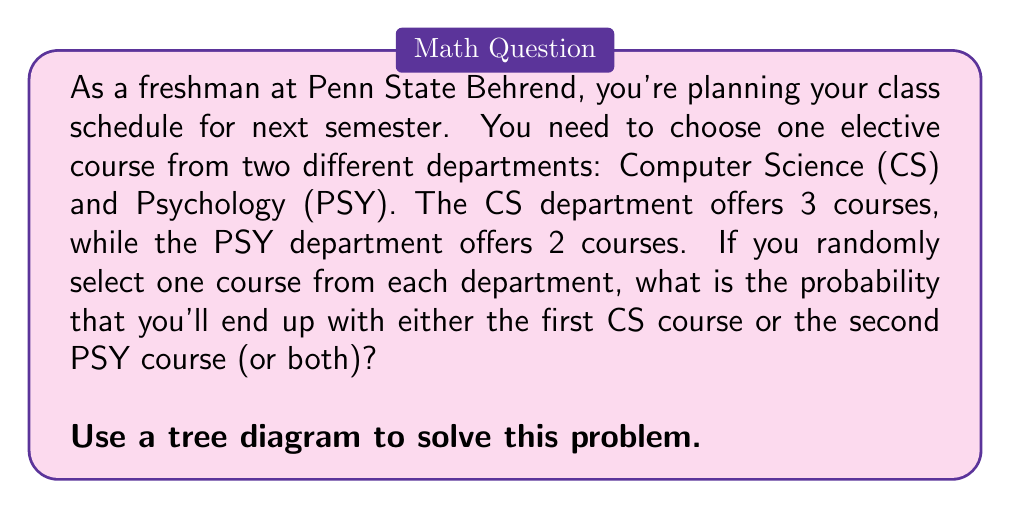Show me your answer to this math problem. Let's approach this step-by-step using a tree diagram:

1) First, let's create our tree diagram:

[asy]
unitsize(1cm);

// Main branches
draw((0,0)--(2,1));
draw((0,0)--(2,0));
draw((0,0)--(2,-1));

// Sub-branches
draw((2,1)--(4,1.5));
draw((2,1)--(4,0.5));
draw((2,0)--(4,0.25));
draw((2,0)--(4,-0.25));
draw((2,-1)--(4,-0.75));
draw((2,-1)--(4,-1.25));

// Labels
label("CS1", (1,1), W);
label("CS2", (1,0), W);
label("CS3", (1,-1), W);
label("PSY1", (3,1.5), E);
label("PSY2", (3,0.5), E);
label("PSY1", (3,0.25), E);
label("PSY2", (3,-0.25), E);
label("PSY1", (3,-0.75), E);
label("PSY2", (3,-1.25), E);

// Probabilities
label("1/3", (1,1), N);
label("1/3", (1,0), N);
label("1/3", (1,-1), N);
label("1/2", (3,1.5), N);
label("1/2", (3,0.5), N);
label("1/2", (3,0.25), N);
label("1/2", (3,-0.25), N);
label("1/2", (3,-0.75), N);
label("1/2", (3,-1.25), N);
[/asy]

2) Now, let's identify the favorable outcomes:
   - CS1 and PSY1
   - CS1 and PSY2
   - CS2 and PSY2
   - CS3 and PSY2

3) Let's calculate the probability of each favorable outcome:
   
   $P(\text{CS1 and PSY1}) = \frac{1}{3} \times \frac{1}{2} = \frac{1}{6}$
   $P(\text{CS1 and PSY2}) = \frac{1}{3} \times \frac{1}{2} = \frac{1}{6}$
   $P(\text{CS2 and PSY2}) = \frac{1}{3} \times \frac{1}{2} = \frac{1}{6}$
   $P(\text{CS3 and PSY2}) = \frac{1}{3} \times \frac{1}{2} = \frac{1}{6}$

4) The total probability is the sum of these individual probabilities:

   $P(\text{total}) = \frac{1}{6} + \frac{1}{6} + \frac{1}{6} + \frac{1}{6} = \frac{4}{6} = \frac{2}{3}$

Therefore, the probability of selecting either the first CS course or the second PSY course (or both) is $\frac{2}{3}$.
Answer: $\frac{2}{3}$ 